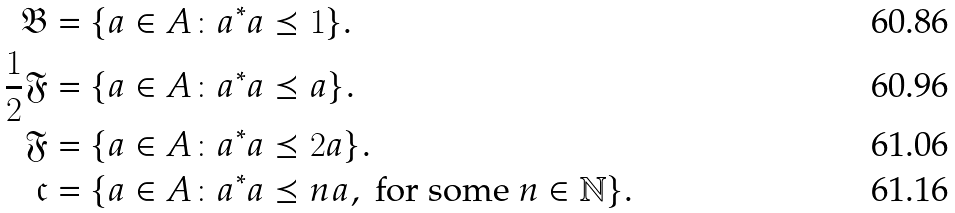<formula> <loc_0><loc_0><loc_500><loc_500>\mathfrak { B } & = \{ a \in A \colon a ^ { * } a \preceq 1 \} . \\ \frac { 1 } { 2 } \mathfrak { F } & = \{ a \in A \colon a ^ { * } a \preceq a \} . \\ \mathfrak { F } & = \{ a \in A \colon a ^ { * } a \preceq 2 a \} . \\ \mathfrak { c } & = \{ a \in A \colon a ^ { * } a \preceq n a , \text { for some } n \in \mathbb { N } \} .</formula> 